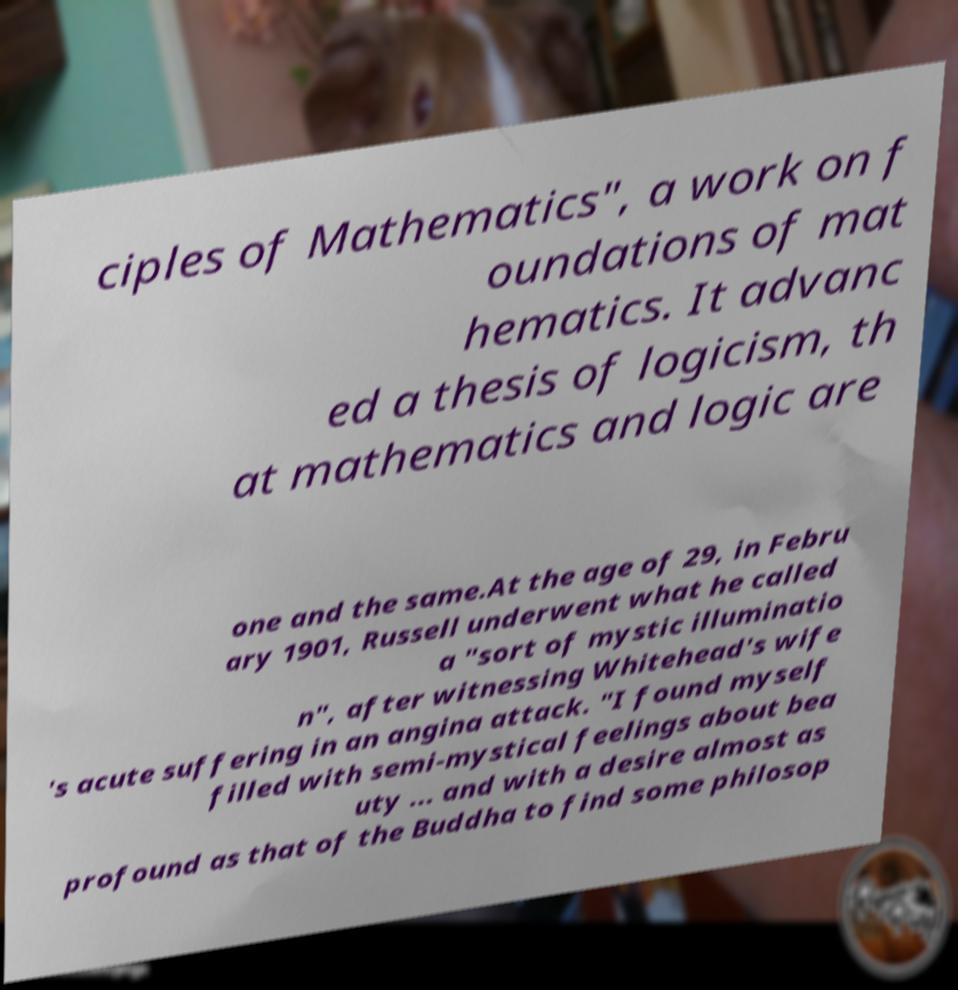Please read and relay the text visible in this image. What does it say? ciples of Mathematics", a work on f oundations of mat hematics. It advanc ed a thesis of logicism, th at mathematics and logic are one and the same.At the age of 29, in Febru ary 1901, Russell underwent what he called a "sort of mystic illuminatio n", after witnessing Whitehead's wife 's acute suffering in an angina attack. "I found myself filled with semi-mystical feelings about bea uty ... and with a desire almost as profound as that of the Buddha to find some philosop 